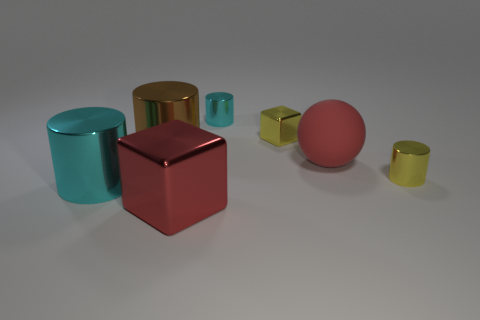Subtract 1 cylinders. How many cylinders are left? 3 Subtract all purple cylinders. Subtract all green spheres. How many cylinders are left? 4 Add 3 yellow cylinders. How many objects exist? 10 Subtract all balls. How many objects are left? 6 Add 4 large yellow metal cylinders. How many large yellow metal cylinders exist? 4 Subtract 0 brown spheres. How many objects are left? 7 Subtract all small yellow metal cylinders. Subtract all big cyan cylinders. How many objects are left? 5 Add 2 large matte things. How many large matte things are left? 3 